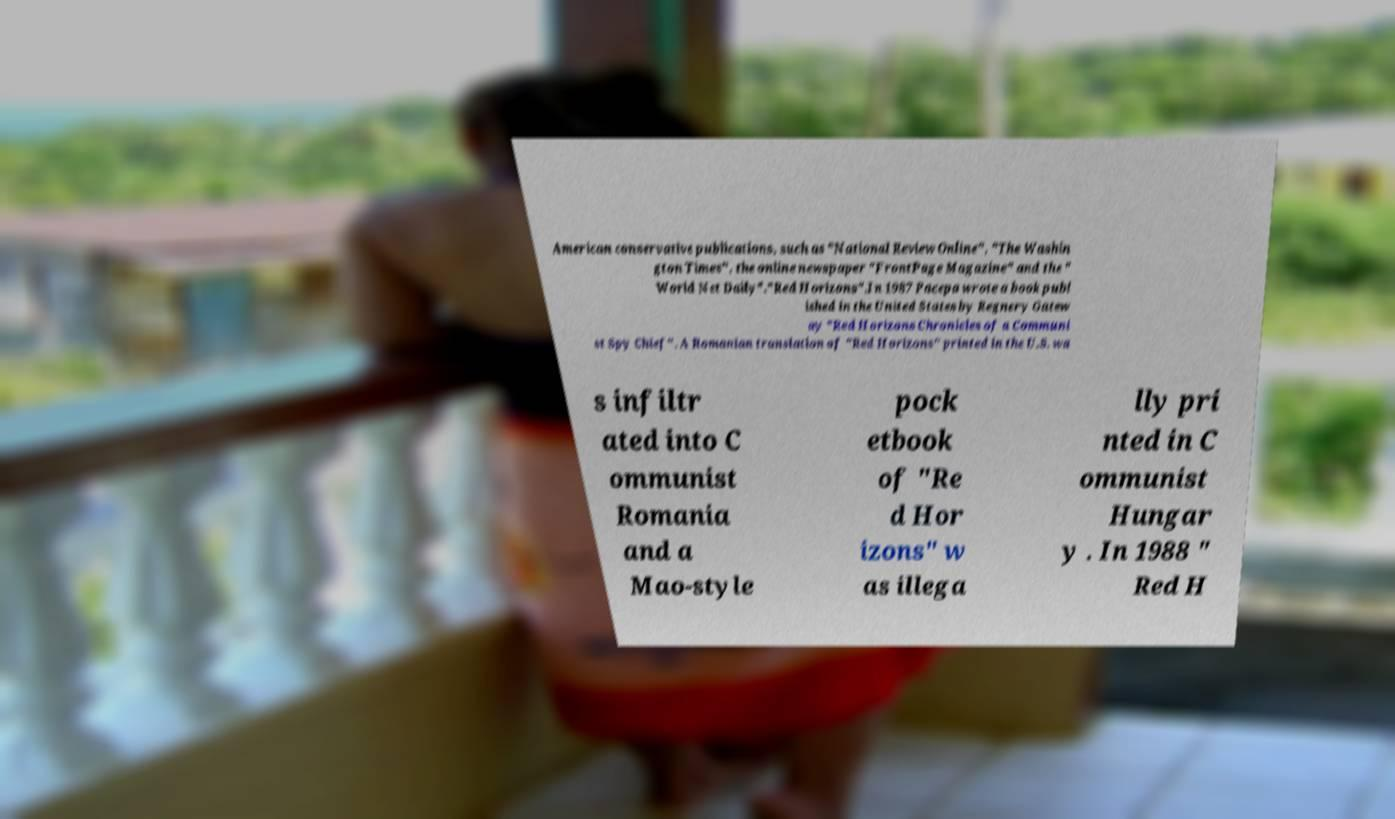What messages or text are displayed in this image? I need them in a readable, typed format. American conservative publications, such as "National Review Online", "The Washin gton Times", the online newspaper "FrontPage Magazine" and the " World Net Daily"."Red Horizons".In 1987 Pacepa wrote a book publ ished in the United States by Regnery Gatew ay "Red Horizons Chronicles of a Communi st Spy Chief". A Romanian translation of "Red Horizons" printed in the U.S. wa s infiltr ated into C ommunist Romania and a Mao-style pock etbook of "Re d Hor izons" w as illega lly pri nted in C ommunist Hungar y . In 1988 " Red H 